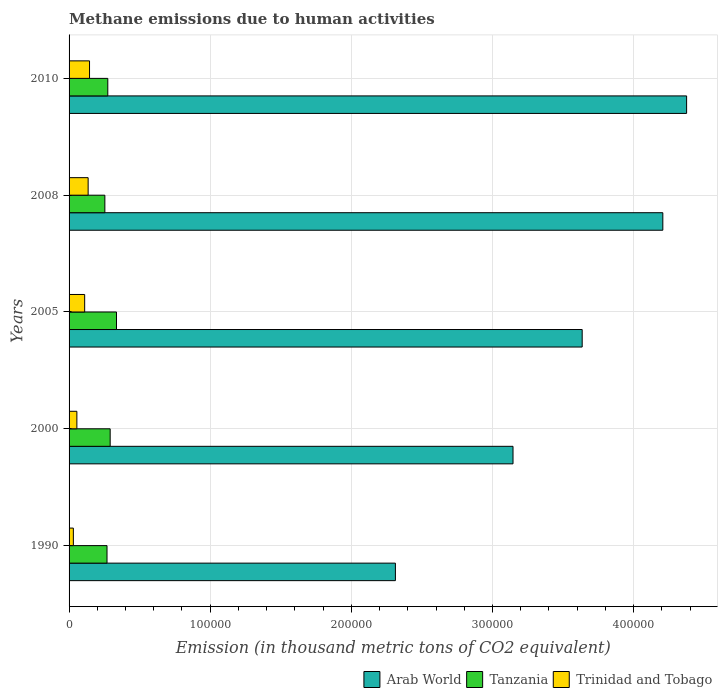Are the number of bars on each tick of the Y-axis equal?
Offer a very short reply. Yes. How many bars are there on the 3rd tick from the top?
Offer a terse response. 3. How many bars are there on the 1st tick from the bottom?
Your answer should be very brief. 3. What is the amount of methane emitted in Tanzania in 1990?
Offer a terse response. 2.69e+04. Across all years, what is the maximum amount of methane emitted in Tanzania?
Offer a very short reply. 3.36e+04. Across all years, what is the minimum amount of methane emitted in Arab World?
Keep it short and to the point. 2.31e+05. In which year was the amount of methane emitted in Trinidad and Tobago maximum?
Offer a terse response. 2010. What is the total amount of methane emitted in Arab World in the graph?
Your answer should be very brief. 1.77e+06. What is the difference between the amount of methane emitted in Trinidad and Tobago in 1990 and that in 2010?
Your response must be concise. -1.15e+04. What is the difference between the amount of methane emitted in Arab World in 2010 and the amount of methane emitted in Trinidad and Tobago in 2005?
Offer a very short reply. 4.27e+05. What is the average amount of methane emitted in Tanzania per year?
Keep it short and to the point. 2.85e+04. In the year 2008, what is the difference between the amount of methane emitted in Tanzania and amount of methane emitted in Trinidad and Tobago?
Your answer should be compact. 1.19e+04. In how many years, is the amount of methane emitted in Tanzania greater than 100000 thousand metric tons?
Ensure brevity in your answer.  0. What is the ratio of the amount of methane emitted in Trinidad and Tobago in 2000 to that in 2010?
Your answer should be very brief. 0.38. Is the amount of methane emitted in Tanzania in 1990 less than that in 2008?
Make the answer very short. No. What is the difference between the highest and the second highest amount of methane emitted in Trinidad and Tobago?
Offer a very short reply. 990.5. What is the difference between the highest and the lowest amount of methane emitted in Arab World?
Offer a very short reply. 2.06e+05. In how many years, is the amount of methane emitted in Arab World greater than the average amount of methane emitted in Arab World taken over all years?
Provide a short and direct response. 3. Is the sum of the amount of methane emitted in Tanzania in 1990 and 2005 greater than the maximum amount of methane emitted in Trinidad and Tobago across all years?
Your answer should be very brief. Yes. What does the 1st bar from the top in 2008 represents?
Give a very brief answer. Trinidad and Tobago. What does the 3rd bar from the bottom in 2005 represents?
Offer a very short reply. Trinidad and Tobago. Is it the case that in every year, the sum of the amount of methane emitted in Tanzania and amount of methane emitted in Trinidad and Tobago is greater than the amount of methane emitted in Arab World?
Offer a terse response. No. Are the values on the major ticks of X-axis written in scientific E-notation?
Give a very brief answer. No. Does the graph contain any zero values?
Offer a very short reply. No. Does the graph contain grids?
Make the answer very short. Yes. Where does the legend appear in the graph?
Give a very brief answer. Bottom right. What is the title of the graph?
Give a very brief answer. Methane emissions due to human activities. What is the label or title of the X-axis?
Ensure brevity in your answer.  Emission (in thousand metric tons of CO2 equivalent). What is the label or title of the Y-axis?
Your answer should be very brief. Years. What is the Emission (in thousand metric tons of CO2 equivalent) in Arab World in 1990?
Your response must be concise. 2.31e+05. What is the Emission (in thousand metric tons of CO2 equivalent) of Tanzania in 1990?
Your answer should be very brief. 2.69e+04. What is the Emission (in thousand metric tons of CO2 equivalent) of Trinidad and Tobago in 1990?
Ensure brevity in your answer.  3037.6. What is the Emission (in thousand metric tons of CO2 equivalent) in Arab World in 2000?
Make the answer very short. 3.15e+05. What is the Emission (in thousand metric tons of CO2 equivalent) of Tanzania in 2000?
Provide a succinct answer. 2.91e+04. What is the Emission (in thousand metric tons of CO2 equivalent) in Trinidad and Tobago in 2000?
Give a very brief answer. 5527.5. What is the Emission (in thousand metric tons of CO2 equivalent) of Arab World in 2005?
Your answer should be compact. 3.64e+05. What is the Emission (in thousand metric tons of CO2 equivalent) of Tanzania in 2005?
Give a very brief answer. 3.36e+04. What is the Emission (in thousand metric tons of CO2 equivalent) of Trinidad and Tobago in 2005?
Provide a short and direct response. 1.11e+04. What is the Emission (in thousand metric tons of CO2 equivalent) of Arab World in 2008?
Your response must be concise. 4.21e+05. What is the Emission (in thousand metric tons of CO2 equivalent) of Tanzania in 2008?
Your response must be concise. 2.54e+04. What is the Emission (in thousand metric tons of CO2 equivalent) of Trinidad and Tobago in 2008?
Make the answer very short. 1.35e+04. What is the Emission (in thousand metric tons of CO2 equivalent) of Arab World in 2010?
Your answer should be very brief. 4.38e+05. What is the Emission (in thousand metric tons of CO2 equivalent) in Tanzania in 2010?
Give a very brief answer. 2.74e+04. What is the Emission (in thousand metric tons of CO2 equivalent) in Trinidad and Tobago in 2010?
Ensure brevity in your answer.  1.45e+04. Across all years, what is the maximum Emission (in thousand metric tons of CO2 equivalent) of Arab World?
Offer a very short reply. 4.38e+05. Across all years, what is the maximum Emission (in thousand metric tons of CO2 equivalent) of Tanzania?
Your answer should be compact. 3.36e+04. Across all years, what is the maximum Emission (in thousand metric tons of CO2 equivalent) of Trinidad and Tobago?
Offer a very short reply. 1.45e+04. Across all years, what is the minimum Emission (in thousand metric tons of CO2 equivalent) of Arab World?
Offer a terse response. 2.31e+05. Across all years, what is the minimum Emission (in thousand metric tons of CO2 equivalent) of Tanzania?
Offer a very short reply. 2.54e+04. Across all years, what is the minimum Emission (in thousand metric tons of CO2 equivalent) in Trinidad and Tobago?
Offer a terse response. 3037.6. What is the total Emission (in thousand metric tons of CO2 equivalent) in Arab World in the graph?
Your response must be concise. 1.77e+06. What is the total Emission (in thousand metric tons of CO2 equivalent) in Tanzania in the graph?
Make the answer very short. 1.42e+05. What is the total Emission (in thousand metric tons of CO2 equivalent) in Trinidad and Tobago in the graph?
Provide a short and direct response. 4.76e+04. What is the difference between the Emission (in thousand metric tons of CO2 equivalent) in Arab World in 1990 and that in 2000?
Ensure brevity in your answer.  -8.33e+04. What is the difference between the Emission (in thousand metric tons of CO2 equivalent) of Tanzania in 1990 and that in 2000?
Offer a terse response. -2232.7. What is the difference between the Emission (in thousand metric tons of CO2 equivalent) in Trinidad and Tobago in 1990 and that in 2000?
Your response must be concise. -2489.9. What is the difference between the Emission (in thousand metric tons of CO2 equivalent) of Arab World in 1990 and that in 2005?
Offer a terse response. -1.32e+05. What is the difference between the Emission (in thousand metric tons of CO2 equivalent) of Tanzania in 1990 and that in 2005?
Your answer should be very brief. -6719. What is the difference between the Emission (in thousand metric tons of CO2 equivalent) in Trinidad and Tobago in 1990 and that in 2005?
Your answer should be compact. -8017.1. What is the difference between the Emission (in thousand metric tons of CO2 equivalent) in Arab World in 1990 and that in 2008?
Offer a terse response. -1.89e+05. What is the difference between the Emission (in thousand metric tons of CO2 equivalent) of Tanzania in 1990 and that in 2008?
Keep it short and to the point. 1531.3. What is the difference between the Emission (in thousand metric tons of CO2 equivalent) in Trinidad and Tobago in 1990 and that in 2008?
Provide a succinct answer. -1.05e+04. What is the difference between the Emission (in thousand metric tons of CO2 equivalent) of Arab World in 1990 and that in 2010?
Keep it short and to the point. -2.06e+05. What is the difference between the Emission (in thousand metric tons of CO2 equivalent) in Tanzania in 1990 and that in 2010?
Provide a succinct answer. -554.2. What is the difference between the Emission (in thousand metric tons of CO2 equivalent) in Trinidad and Tobago in 1990 and that in 2010?
Make the answer very short. -1.15e+04. What is the difference between the Emission (in thousand metric tons of CO2 equivalent) of Arab World in 2000 and that in 2005?
Offer a terse response. -4.90e+04. What is the difference between the Emission (in thousand metric tons of CO2 equivalent) in Tanzania in 2000 and that in 2005?
Ensure brevity in your answer.  -4486.3. What is the difference between the Emission (in thousand metric tons of CO2 equivalent) in Trinidad and Tobago in 2000 and that in 2005?
Offer a terse response. -5527.2. What is the difference between the Emission (in thousand metric tons of CO2 equivalent) in Arab World in 2000 and that in 2008?
Offer a terse response. -1.06e+05. What is the difference between the Emission (in thousand metric tons of CO2 equivalent) in Tanzania in 2000 and that in 2008?
Make the answer very short. 3764. What is the difference between the Emission (in thousand metric tons of CO2 equivalent) of Trinidad and Tobago in 2000 and that in 2008?
Offer a very short reply. -7981.1. What is the difference between the Emission (in thousand metric tons of CO2 equivalent) in Arab World in 2000 and that in 2010?
Make the answer very short. -1.23e+05. What is the difference between the Emission (in thousand metric tons of CO2 equivalent) of Tanzania in 2000 and that in 2010?
Provide a succinct answer. 1678.5. What is the difference between the Emission (in thousand metric tons of CO2 equivalent) in Trinidad and Tobago in 2000 and that in 2010?
Keep it short and to the point. -8971.6. What is the difference between the Emission (in thousand metric tons of CO2 equivalent) in Arab World in 2005 and that in 2008?
Your answer should be compact. -5.71e+04. What is the difference between the Emission (in thousand metric tons of CO2 equivalent) of Tanzania in 2005 and that in 2008?
Your response must be concise. 8250.3. What is the difference between the Emission (in thousand metric tons of CO2 equivalent) in Trinidad and Tobago in 2005 and that in 2008?
Ensure brevity in your answer.  -2453.9. What is the difference between the Emission (in thousand metric tons of CO2 equivalent) of Arab World in 2005 and that in 2010?
Provide a short and direct response. -7.40e+04. What is the difference between the Emission (in thousand metric tons of CO2 equivalent) of Tanzania in 2005 and that in 2010?
Your response must be concise. 6164.8. What is the difference between the Emission (in thousand metric tons of CO2 equivalent) of Trinidad and Tobago in 2005 and that in 2010?
Provide a succinct answer. -3444.4. What is the difference between the Emission (in thousand metric tons of CO2 equivalent) of Arab World in 2008 and that in 2010?
Ensure brevity in your answer.  -1.69e+04. What is the difference between the Emission (in thousand metric tons of CO2 equivalent) of Tanzania in 2008 and that in 2010?
Provide a succinct answer. -2085.5. What is the difference between the Emission (in thousand metric tons of CO2 equivalent) in Trinidad and Tobago in 2008 and that in 2010?
Offer a very short reply. -990.5. What is the difference between the Emission (in thousand metric tons of CO2 equivalent) of Arab World in 1990 and the Emission (in thousand metric tons of CO2 equivalent) of Tanzania in 2000?
Your response must be concise. 2.02e+05. What is the difference between the Emission (in thousand metric tons of CO2 equivalent) of Arab World in 1990 and the Emission (in thousand metric tons of CO2 equivalent) of Trinidad and Tobago in 2000?
Make the answer very short. 2.26e+05. What is the difference between the Emission (in thousand metric tons of CO2 equivalent) in Tanzania in 1990 and the Emission (in thousand metric tons of CO2 equivalent) in Trinidad and Tobago in 2000?
Offer a terse response. 2.14e+04. What is the difference between the Emission (in thousand metric tons of CO2 equivalent) of Arab World in 1990 and the Emission (in thousand metric tons of CO2 equivalent) of Tanzania in 2005?
Your answer should be very brief. 1.98e+05. What is the difference between the Emission (in thousand metric tons of CO2 equivalent) in Arab World in 1990 and the Emission (in thousand metric tons of CO2 equivalent) in Trinidad and Tobago in 2005?
Keep it short and to the point. 2.20e+05. What is the difference between the Emission (in thousand metric tons of CO2 equivalent) in Tanzania in 1990 and the Emission (in thousand metric tons of CO2 equivalent) in Trinidad and Tobago in 2005?
Provide a short and direct response. 1.58e+04. What is the difference between the Emission (in thousand metric tons of CO2 equivalent) of Arab World in 1990 and the Emission (in thousand metric tons of CO2 equivalent) of Tanzania in 2008?
Provide a short and direct response. 2.06e+05. What is the difference between the Emission (in thousand metric tons of CO2 equivalent) of Arab World in 1990 and the Emission (in thousand metric tons of CO2 equivalent) of Trinidad and Tobago in 2008?
Offer a very short reply. 2.18e+05. What is the difference between the Emission (in thousand metric tons of CO2 equivalent) of Tanzania in 1990 and the Emission (in thousand metric tons of CO2 equivalent) of Trinidad and Tobago in 2008?
Keep it short and to the point. 1.34e+04. What is the difference between the Emission (in thousand metric tons of CO2 equivalent) of Arab World in 1990 and the Emission (in thousand metric tons of CO2 equivalent) of Tanzania in 2010?
Your response must be concise. 2.04e+05. What is the difference between the Emission (in thousand metric tons of CO2 equivalent) of Arab World in 1990 and the Emission (in thousand metric tons of CO2 equivalent) of Trinidad and Tobago in 2010?
Your answer should be very brief. 2.17e+05. What is the difference between the Emission (in thousand metric tons of CO2 equivalent) of Tanzania in 1990 and the Emission (in thousand metric tons of CO2 equivalent) of Trinidad and Tobago in 2010?
Your answer should be very brief. 1.24e+04. What is the difference between the Emission (in thousand metric tons of CO2 equivalent) in Arab World in 2000 and the Emission (in thousand metric tons of CO2 equivalent) in Tanzania in 2005?
Your response must be concise. 2.81e+05. What is the difference between the Emission (in thousand metric tons of CO2 equivalent) of Arab World in 2000 and the Emission (in thousand metric tons of CO2 equivalent) of Trinidad and Tobago in 2005?
Provide a short and direct response. 3.04e+05. What is the difference between the Emission (in thousand metric tons of CO2 equivalent) in Tanzania in 2000 and the Emission (in thousand metric tons of CO2 equivalent) in Trinidad and Tobago in 2005?
Offer a very short reply. 1.81e+04. What is the difference between the Emission (in thousand metric tons of CO2 equivalent) in Arab World in 2000 and the Emission (in thousand metric tons of CO2 equivalent) in Tanzania in 2008?
Your response must be concise. 2.89e+05. What is the difference between the Emission (in thousand metric tons of CO2 equivalent) in Arab World in 2000 and the Emission (in thousand metric tons of CO2 equivalent) in Trinidad and Tobago in 2008?
Provide a short and direct response. 3.01e+05. What is the difference between the Emission (in thousand metric tons of CO2 equivalent) of Tanzania in 2000 and the Emission (in thousand metric tons of CO2 equivalent) of Trinidad and Tobago in 2008?
Your answer should be compact. 1.56e+04. What is the difference between the Emission (in thousand metric tons of CO2 equivalent) of Arab World in 2000 and the Emission (in thousand metric tons of CO2 equivalent) of Tanzania in 2010?
Your response must be concise. 2.87e+05. What is the difference between the Emission (in thousand metric tons of CO2 equivalent) in Arab World in 2000 and the Emission (in thousand metric tons of CO2 equivalent) in Trinidad and Tobago in 2010?
Make the answer very short. 3.00e+05. What is the difference between the Emission (in thousand metric tons of CO2 equivalent) of Tanzania in 2000 and the Emission (in thousand metric tons of CO2 equivalent) of Trinidad and Tobago in 2010?
Offer a very short reply. 1.46e+04. What is the difference between the Emission (in thousand metric tons of CO2 equivalent) of Arab World in 2005 and the Emission (in thousand metric tons of CO2 equivalent) of Tanzania in 2008?
Make the answer very short. 3.38e+05. What is the difference between the Emission (in thousand metric tons of CO2 equivalent) of Arab World in 2005 and the Emission (in thousand metric tons of CO2 equivalent) of Trinidad and Tobago in 2008?
Your answer should be compact. 3.50e+05. What is the difference between the Emission (in thousand metric tons of CO2 equivalent) of Tanzania in 2005 and the Emission (in thousand metric tons of CO2 equivalent) of Trinidad and Tobago in 2008?
Give a very brief answer. 2.01e+04. What is the difference between the Emission (in thousand metric tons of CO2 equivalent) of Arab World in 2005 and the Emission (in thousand metric tons of CO2 equivalent) of Tanzania in 2010?
Make the answer very short. 3.36e+05. What is the difference between the Emission (in thousand metric tons of CO2 equivalent) of Arab World in 2005 and the Emission (in thousand metric tons of CO2 equivalent) of Trinidad and Tobago in 2010?
Offer a terse response. 3.49e+05. What is the difference between the Emission (in thousand metric tons of CO2 equivalent) of Tanzania in 2005 and the Emission (in thousand metric tons of CO2 equivalent) of Trinidad and Tobago in 2010?
Your response must be concise. 1.91e+04. What is the difference between the Emission (in thousand metric tons of CO2 equivalent) of Arab World in 2008 and the Emission (in thousand metric tons of CO2 equivalent) of Tanzania in 2010?
Your response must be concise. 3.93e+05. What is the difference between the Emission (in thousand metric tons of CO2 equivalent) of Arab World in 2008 and the Emission (in thousand metric tons of CO2 equivalent) of Trinidad and Tobago in 2010?
Make the answer very short. 4.06e+05. What is the difference between the Emission (in thousand metric tons of CO2 equivalent) of Tanzania in 2008 and the Emission (in thousand metric tons of CO2 equivalent) of Trinidad and Tobago in 2010?
Provide a succinct answer. 1.09e+04. What is the average Emission (in thousand metric tons of CO2 equivalent) in Arab World per year?
Make the answer very short. 3.54e+05. What is the average Emission (in thousand metric tons of CO2 equivalent) in Tanzania per year?
Offer a terse response. 2.85e+04. What is the average Emission (in thousand metric tons of CO2 equivalent) in Trinidad and Tobago per year?
Provide a short and direct response. 9525.5. In the year 1990, what is the difference between the Emission (in thousand metric tons of CO2 equivalent) of Arab World and Emission (in thousand metric tons of CO2 equivalent) of Tanzania?
Make the answer very short. 2.04e+05. In the year 1990, what is the difference between the Emission (in thousand metric tons of CO2 equivalent) of Arab World and Emission (in thousand metric tons of CO2 equivalent) of Trinidad and Tobago?
Offer a very short reply. 2.28e+05. In the year 1990, what is the difference between the Emission (in thousand metric tons of CO2 equivalent) of Tanzania and Emission (in thousand metric tons of CO2 equivalent) of Trinidad and Tobago?
Your answer should be compact. 2.39e+04. In the year 2000, what is the difference between the Emission (in thousand metric tons of CO2 equivalent) of Arab World and Emission (in thousand metric tons of CO2 equivalent) of Tanzania?
Your answer should be very brief. 2.85e+05. In the year 2000, what is the difference between the Emission (in thousand metric tons of CO2 equivalent) in Arab World and Emission (in thousand metric tons of CO2 equivalent) in Trinidad and Tobago?
Your response must be concise. 3.09e+05. In the year 2000, what is the difference between the Emission (in thousand metric tons of CO2 equivalent) in Tanzania and Emission (in thousand metric tons of CO2 equivalent) in Trinidad and Tobago?
Your answer should be compact. 2.36e+04. In the year 2005, what is the difference between the Emission (in thousand metric tons of CO2 equivalent) in Arab World and Emission (in thousand metric tons of CO2 equivalent) in Tanzania?
Your answer should be compact. 3.30e+05. In the year 2005, what is the difference between the Emission (in thousand metric tons of CO2 equivalent) of Arab World and Emission (in thousand metric tons of CO2 equivalent) of Trinidad and Tobago?
Your answer should be compact. 3.53e+05. In the year 2005, what is the difference between the Emission (in thousand metric tons of CO2 equivalent) of Tanzania and Emission (in thousand metric tons of CO2 equivalent) of Trinidad and Tobago?
Your response must be concise. 2.26e+04. In the year 2008, what is the difference between the Emission (in thousand metric tons of CO2 equivalent) of Arab World and Emission (in thousand metric tons of CO2 equivalent) of Tanzania?
Ensure brevity in your answer.  3.95e+05. In the year 2008, what is the difference between the Emission (in thousand metric tons of CO2 equivalent) in Arab World and Emission (in thousand metric tons of CO2 equivalent) in Trinidad and Tobago?
Provide a succinct answer. 4.07e+05. In the year 2008, what is the difference between the Emission (in thousand metric tons of CO2 equivalent) in Tanzania and Emission (in thousand metric tons of CO2 equivalent) in Trinidad and Tobago?
Give a very brief answer. 1.19e+04. In the year 2010, what is the difference between the Emission (in thousand metric tons of CO2 equivalent) of Arab World and Emission (in thousand metric tons of CO2 equivalent) of Tanzania?
Keep it short and to the point. 4.10e+05. In the year 2010, what is the difference between the Emission (in thousand metric tons of CO2 equivalent) in Arab World and Emission (in thousand metric tons of CO2 equivalent) in Trinidad and Tobago?
Offer a very short reply. 4.23e+05. In the year 2010, what is the difference between the Emission (in thousand metric tons of CO2 equivalent) of Tanzania and Emission (in thousand metric tons of CO2 equivalent) of Trinidad and Tobago?
Ensure brevity in your answer.  1.29e+04. What is the ratio of the Emission (in thousand metric tons of CO2 equivalent) in Arab World in 1990 to that in 2000?
Make the answer very short. 0.74. What is the ratio of the Emission (in thousand metric tons of CO2 equivalent) in Tanzania in 1990 to that in 2000?
Keep it short and to the point. 0.92. What is the ratio of the Emission (in thousand metric tons of CO2 equivalent) of Trinidad and Tobago in 1990 to that in 2000?
Make the answer very short. 0.55. What is the ratio of the Emission (in thousand metric tons of CO2 equivalent) in Arab World in 1990 to that in 2005?
Provide a succinct answer. 0.64. What is the ratio of the Emission (in thousand metric tons of CO2 equivalent) in Tanzania in 1990 to that in 2005?
Give a very brief answer. 0.8. What is the ratio of the Emission (in thousand metric tons of CO2 equivalent) in Trinidad and Tobago in 1990 to that in 2005?
Ensure brevity in your answer.  0.27. What is the ratio of the Emission (in thousand metric tons of CO2 equivalent) in Arab World in 1990 to that in 2008?
Offer a very short reply. 0.55. What is the ratio of the Emission (in thousand metric tons of CO2 equivalent) of Tanzania in 1990 to that in 2008?
Offer a very short reply. 1.06. What is the ratio of the Emission (in thousand metric tons of CO2 equivalent) in Trinidad and Tobago in 1990 to that in 2008?
Your response must be concise. 0.22. What is the ratio of the Emission (in thousand metric tons of CO2 equivalent) of Arab World in 1990 to that in 2010?
Your response must be concise. 0.53. What is the ratio of the Emission (in thousand metric tons of CO2 equivalent) of Tanzania in 1990 to that in 2010?
Offer a very short reply. 0.98. What is the ratio of the Emission (in thousand metric tons of CO2 equivalent) in Trinidad and Tobago in 1990 to that in 2010?
Ensure brevity in your answer.  0.21. What is the ratio of the Emission (in thousand metric tons of CO2 equivalent) in Arab World in 2000 to that in 2005?
Make the answer very short. 0.87. What is the ratio of the Emission (in thousand metric tons of CO2 equivalent) in Tanzania in 2000 to that in 2005?
Make the answer very short. 0.87. What is the ratio of the Emission (in thousand metric tons of CO2 equivalent) in Arab World in 2000 to that in 2008?
Your answer should be compact. 0.75. What is the ratio of the Emission (in thousand metric tons of CO2 equivalent) of Tanzania in 2000 to that in 2008?
Keep it short and to the point. 1.15. What is the ratio of the Emission (in thousand metric tons of CO2 equivalent) of Trinidad and Tobago in 2000 to that in 2008?
Offer a very short reply. 0.41. What is the ratio of the Emission (in thousand metric tons of CO2 equivalent) of Arab World in 2000 to that in 2010?
Provide a succinct answer. 0.72. What is the ratio of the Emission (in thousand metric tons of CO2 equivalent) of Tanzania in 2000 to that in 2010?
Ensure brevity in your answer.  1.06. What is the ratio of the Emission (in thousand metric tons of CO2 equivalent) in Trinidad and Tobago in 2000 to that in 2010?
Provide a succinct answer. 0.38. What is the ratio of the Emission (in thousand metric tons of CO2 equivalent) of Arab World in 2005 to that in 2008?
Provide a short and direct response. 0.86. What is the ratio of the Emission (in thousand metric tons of CO2 equivalent) in Tanzania in 2005 to that in 2008?
Keep it short and to the point. 1.33. What is the ratio of the Emission (in thousand metric tons of CO2 equivalent) in Trinidad and Tobago in 2005 to that in 2008?
Keep it short and to the point. 0.82. What is the ratio of the Emission (in thousand metric tons of CO2 equivalent) in Arab World in 2005 to that in 2010?
Provide a short and direct response. 0.83. What is the ratio of the Emission (in thousand metric tons of CO2 equivalent) in Tanzania in 2005 to that in 2010?
Give a very brief answer. 1.22. What is the ratio of the Emission (in thousand metric tons of CO2 equivalent) of Trinidad and Tobago in 2005 to that in 2010?
Keep it short and to the point. 0.76. What is the ratio of the Emission (in thousand metric tons of CO2 equivalent) of Arab World in 2008 to that in 2010?
Provide a short and direct response. 0.96. What is the ratio of the Emission (in thousand metric tons of CO2 equivalent) of Tanzania in 2008 to that in 2010?
Provide a short and direct response. 0.92. What is the ratio of the Emission (in thousand metric tons of CO2 equivalent) in Trinidad and Tobago in 2008 to that in 2010?
Provide a succinct answer. 0.93. What is the difference between the highest and the second highest Emission (in thousand metric tons of CO2 equivalent) in Arab World?
Your answer should be very brief. 1.69e+04. What is the difference between the highest and the second highest Emission (in thousand metric tons of CO2 equivalent) of Tanzania?
Ensure brevity in your answer.  4486.3. What is the difference between the highest and the second highest Emission (in thousand metric tons of CO2 equivalent) in Trinidad and Tobago?
Give a very brief answer. 990.5. What is the difference between the highest and the lowest Emission (in thousand metric tons of CO2 equivalent) of Arab World?
Provide a short and direct response. 2.06e+05. What is the difference between the highest and the lowest Emission (in thousand metric tons of CO2 equivalent) of Tanzania?
Provide a succinct answer. 8250.3. What is the difference between the highest and the lowest Emission (in thousand metric tons of CO2 equivalent) of Trinidad and Tobago?
Keep it short and to the point. 1.15e+04. 